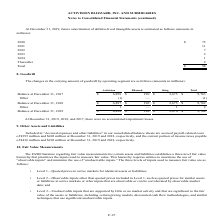According to Activision Blizzard's financial document, What was the balance in the carrying amount of goodwill by Blizzard in 2017? According to the financial document, $190 (in millions). The relevant text states: "Balance at December 31, 2017 $ 6,898 $ 190 $ 2,675 $ 9,763..." Also, What was the balance in the carrying amount of goodwill by King in 2018? According to the financial document, $2,675 (in millions). The relevant text states: "Balance at December 31, 2017 $ 6,898 $ 190 $ 2,675 $ 9,763..." Also, What was the balance in the carrying amount of goodwill by Activision in 2019? According to the financial document, $6,898 (in millions). The relevant text states: "Balance at December 31, 2017 $ 6,898 $ 190 $ 2,675 $ 9,763..." Also, can you calculate: What was the difference in balance in 2017 between Activision and Blizzard? Based on the calculation: $6,898-$190, the result is 6708 (in millions). This is based on the information: "Balance at December 31, 2017 $ 6,898 $ 190 $ 2,675 $ 9,763 Balance at December 31, 2017 $ 6,898 $ 190 $ 2,675 $ 9,763..." The key data points involved are: 190, 6,898. Also, can you calculate: What was the difference in balance in 2019 between Activision and King? Based on the calculation: $6,898-$2,676, the result is 4222 (in millions). This is based on the information: "Balance at December 31, 2019 $ 6,898 $ 190 $ 2,676 $ 9,764 Balance at December 31, 2017 $ 6,898 $ 190 $ 2,675 $ 9,763..." The key data points involved are: 2,676, 6,898. Also, can you calculate: What is the percentage of total balance in 2018 that consists of balance by King? Based on the calculation: $2,675/$9,762, the result is 27.4 (percentage). This is based on the information: "ance at December 31, 2018 $ 6,897 $ 190 $ 2,675 $ 9,762 Balance at December 31, 2017 $ 6,898 $ 190 $ 2,675 $ 9,763..." The key data points involved are: 2,675, 9,762. 